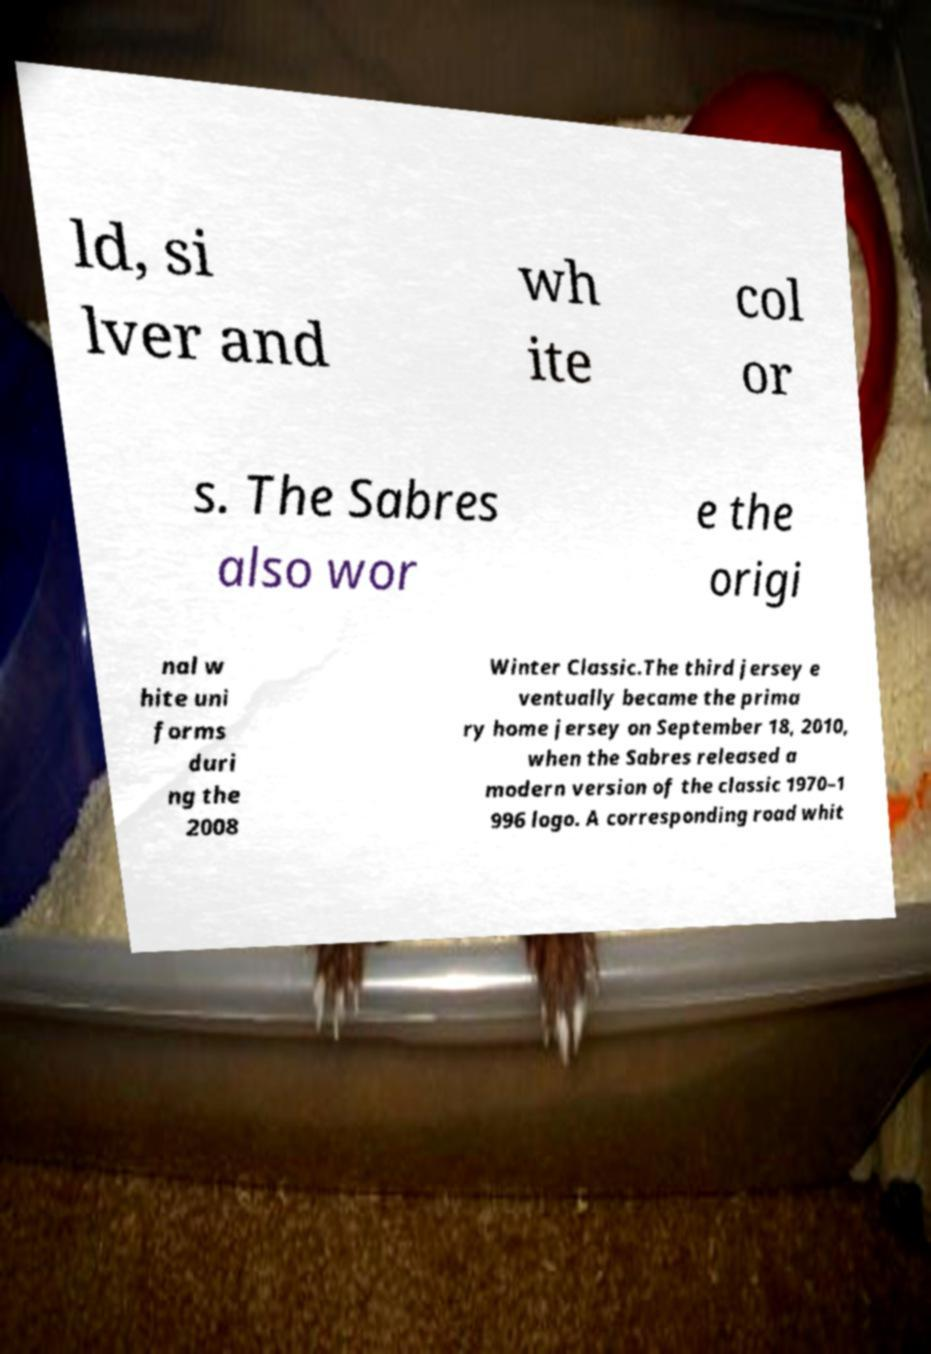Please read and relay the text visible in this image. What does it say? ld, si lver and wh ite col or s. The Sabres also wor e the origi nal w hite uni forms duri ng the 2008 Winter Classic.The third jersey e ventually became the prima ry home jersey on September 18, 2010, when the Sabres released a modern version of the classic 1970–1 996 logo. A corresponding road whit 